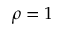Convert formula to latex. <formula><loc_0><loc_0><loc_500><loc_500>\rho = 1</formula> 